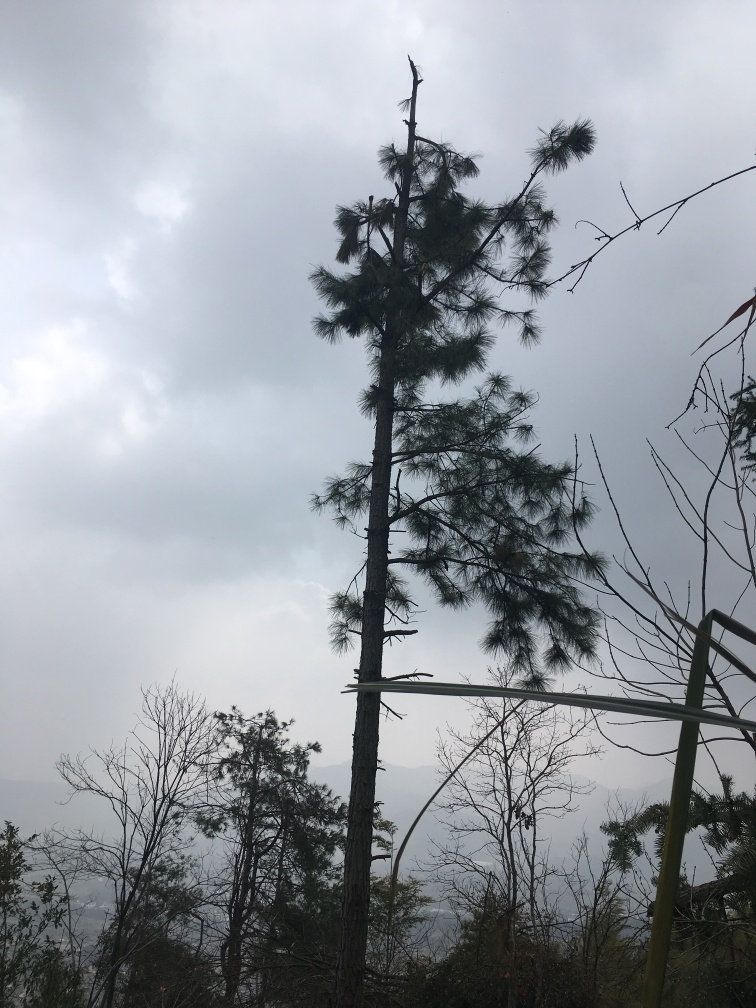Can you tell me what the weather looks like in the image? The weather in the image gives off an overcast impression with many clouds suggesting a cool or possibly damp environment. The possibility of recent or impending rain can be inferred from the heavy cloud cover. 